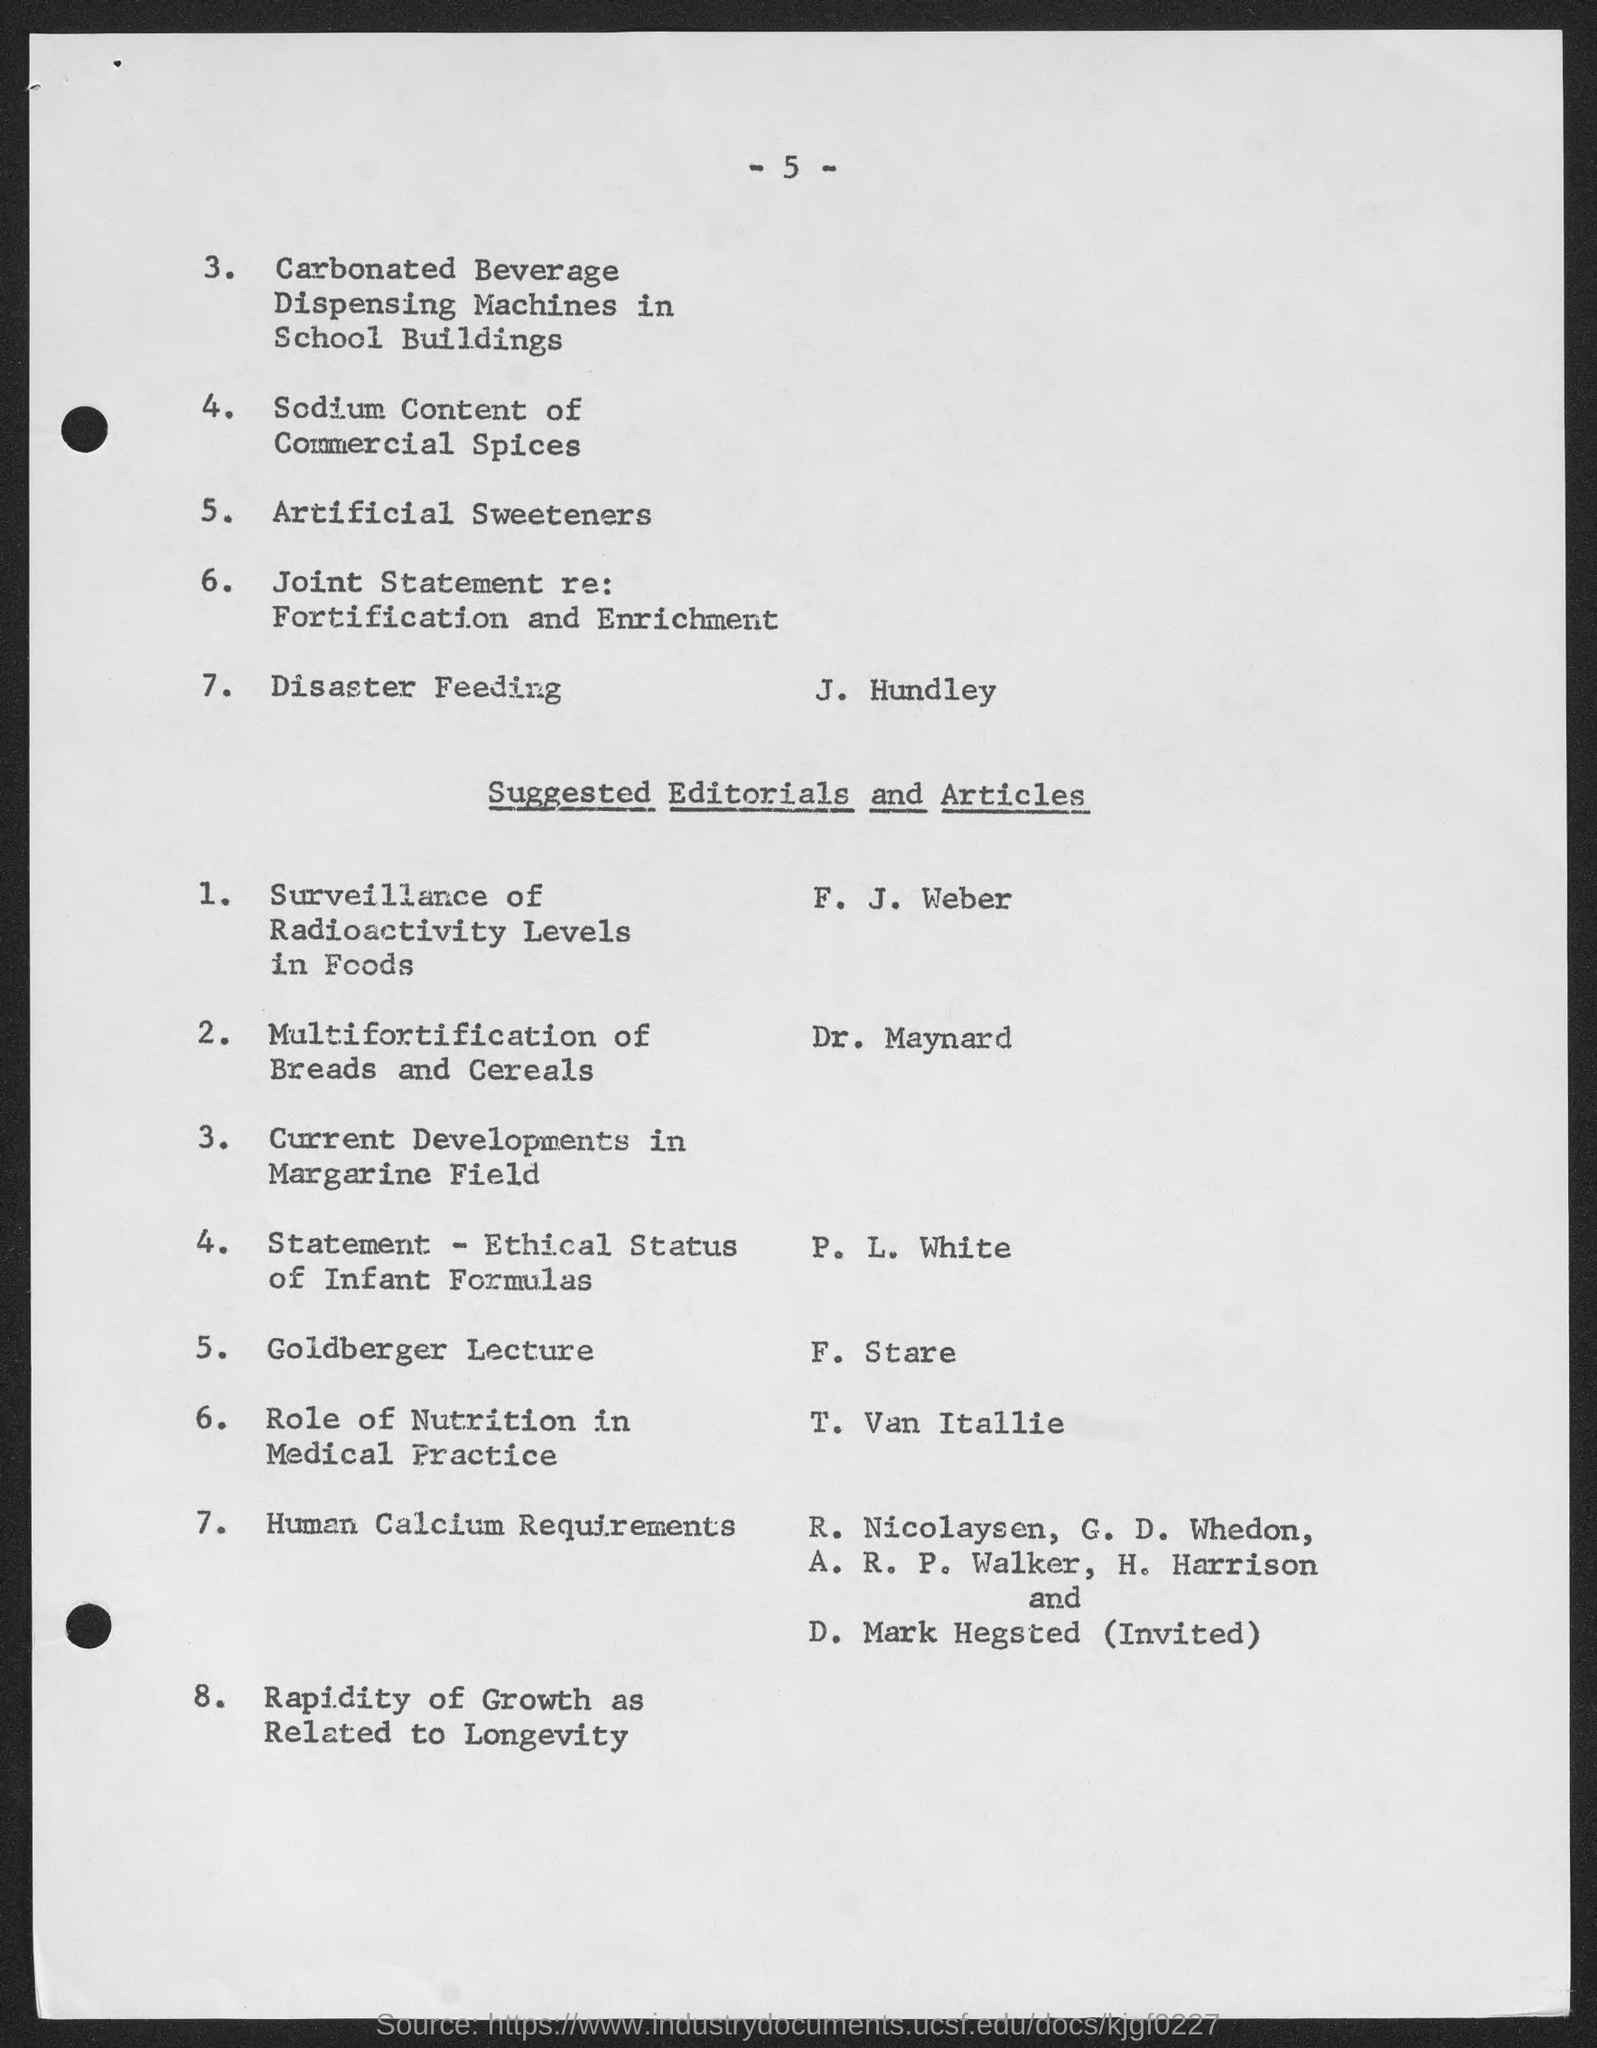Point out several critical features in this image. The number at the top of the page is five. 